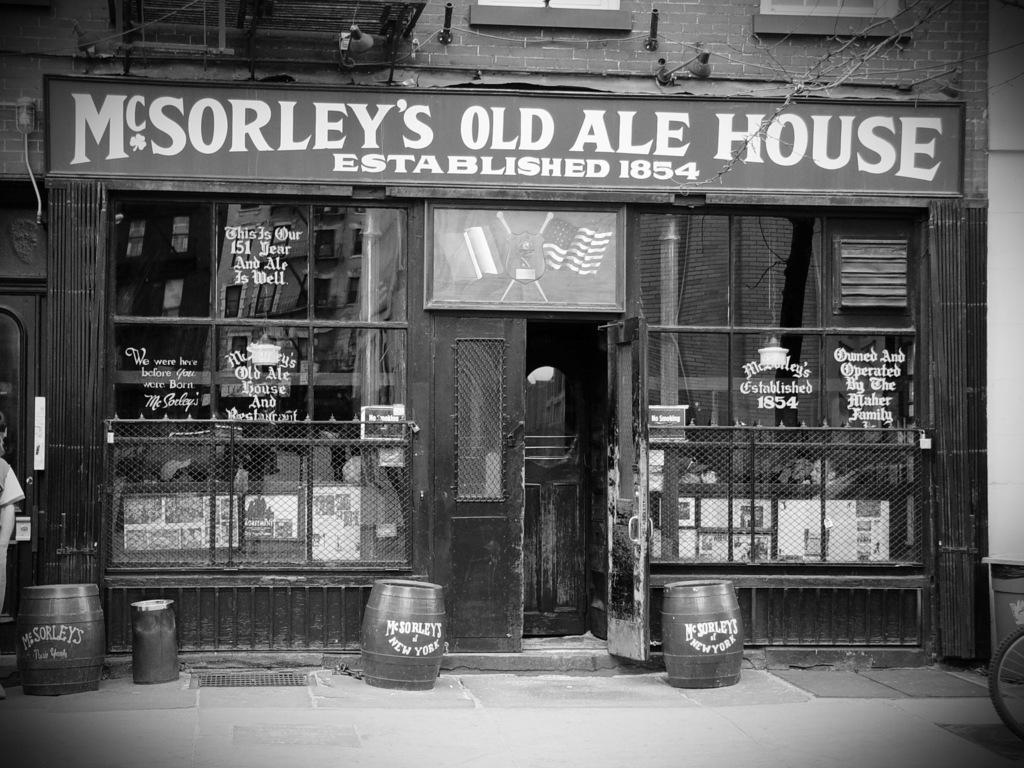Please provide a concise description of this image. In this image I can see a building, few doors, few boards and both side of these doors, I can see something is written. In front I can see few containers and on these containers I can see something is written. 